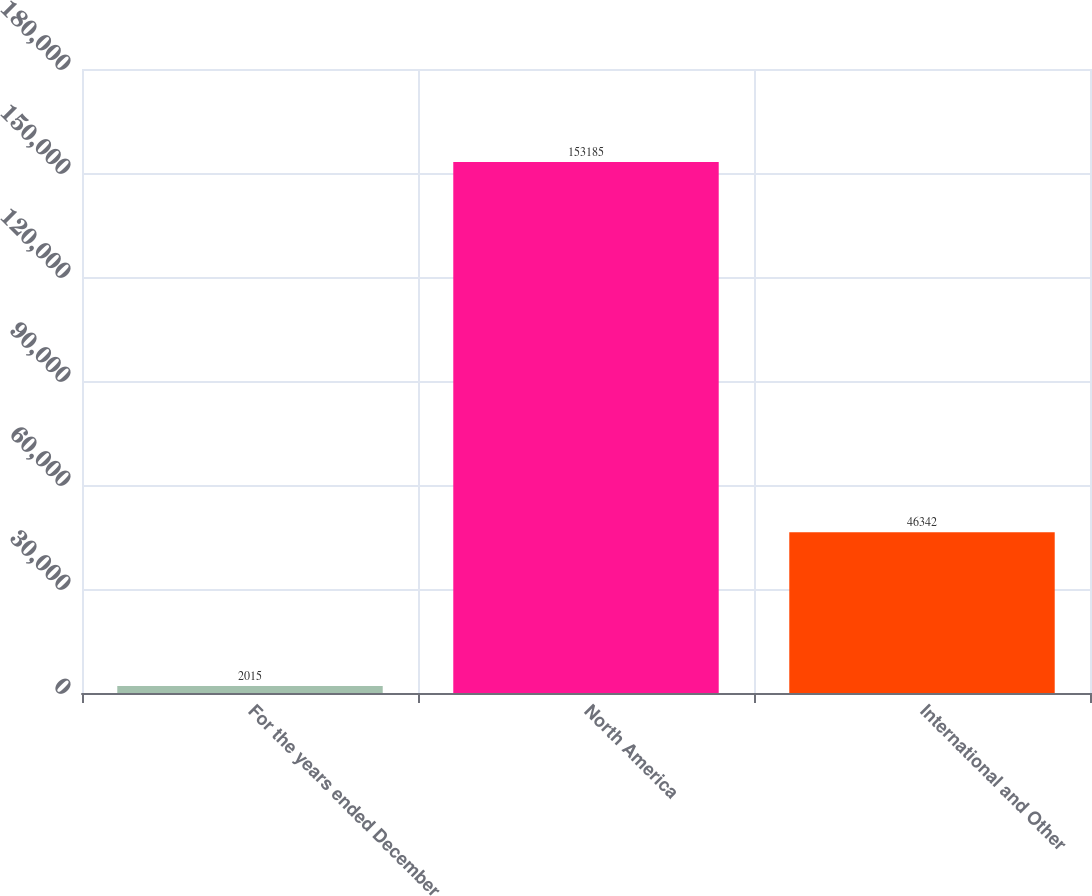Convert chart. <chart><loc_0><loc_0><loc_500><loc_500><bar_chart><fcel>For the years ended December<fcel>North America<fcel>International and Other<nl><fcel>2015<fcel>153185<fcel>46342<nl></chart> 